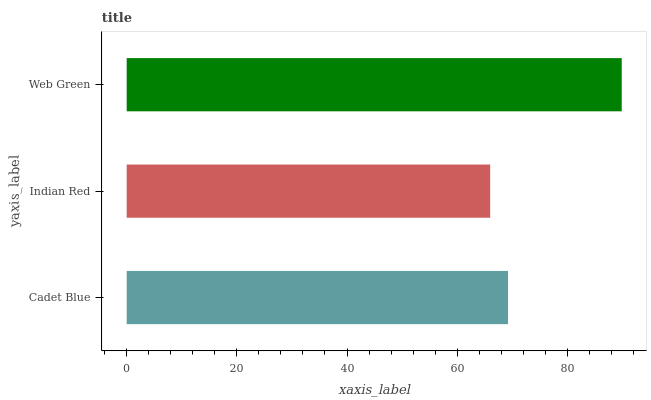Is Indian Red the minimum?
Answer yes or no. Yes. Is Web Green the maximum?
Answer yes or no. Yes. Is Web Green the minimum?
Answer yes or no. No. Is Indian Red the maximum?
Answer yes or no. No. Is Web Green greater than Indian Red?
Answer yes or no. Yes. Is Indian Red less than Web Green?
Answer yes or no. Yes. Is Indian Red greater than Web Green?
Answer yes or no. No. Is Web Green less than Indian Red?
Answer yes or no. No. Is Cadet Blue the high median?
Answer yes or no. Yes. Is Cadet Blue the low median?
Answer yes or no. Yes. Is Indian Red the high median?
Answer yes or no. No. Is Web Green the low median?
Answer yes or no. No. 